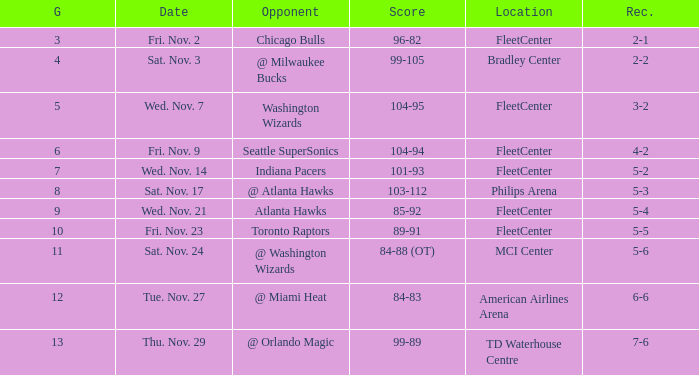Which opponent has a score of 84-88 (ot)? @ Washington Wizards. 